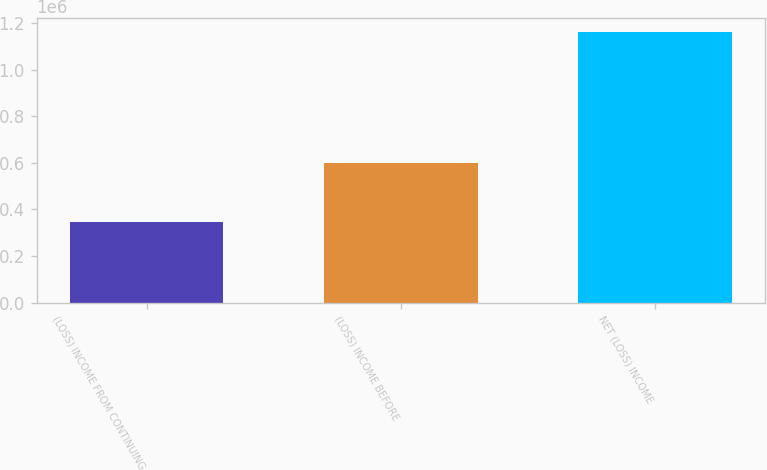Convert chart to OTSL. <chart><loc_0><loc_0><loc_500><loc_500><bar_chart><fcel>(LOSS) INCOME FROM CONTINUING<fcel>(LOSS) INCOME BEFORE<fcel>NET (LOSS) INCOME<nl><fcel>345803<fcel>600922<fcel>1.16354e+06<nl></chart> 